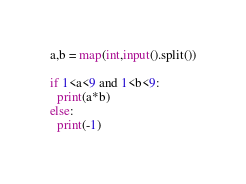<code> <loc_0><loc_0><loc_500><loc_500><_Python_>a,b = map(int,input().split())

if 1<a<9 and 1<b<9:
  print(a*b)
else:
  print(-1)</code> 